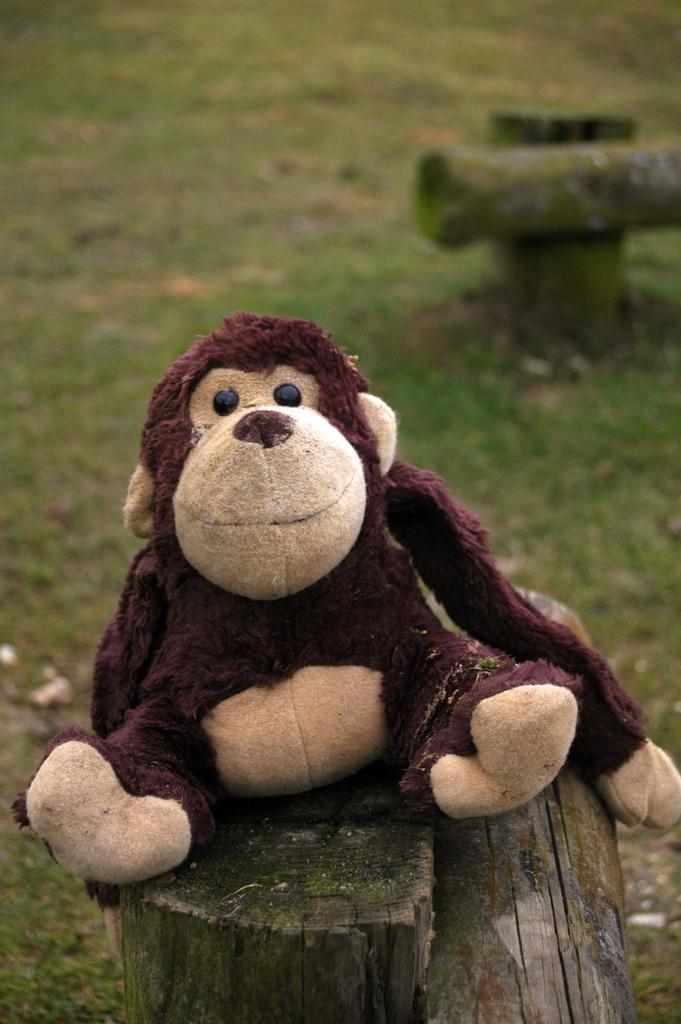What type of toy is present in the image? There is a brown color monkey toy in the image. Where is the monkey toy positioned? The monkey toy is sitting on a tree trunk. What can be seen in the background of the image? There is a grass lawn in the background of the image. What type of fruit is hanging from the tree trunk in the image? There is no fruit present in the image; it only features a monkey toy sitting on a tree trunk. 